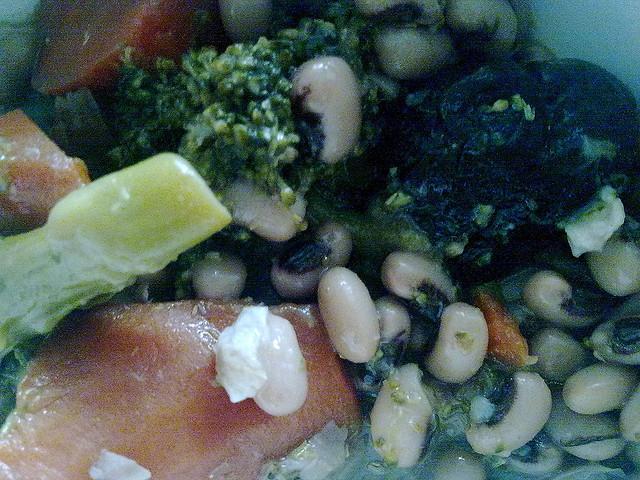Is this a vegetarian dish?
Keep it brief. No. How many artichokes are in the dish?
Quick response, please. 1. Is this in the ocean?
Give a very brief answer. No. Do you see any animals?
Keep it brief. No. 